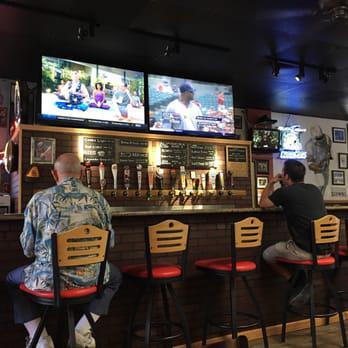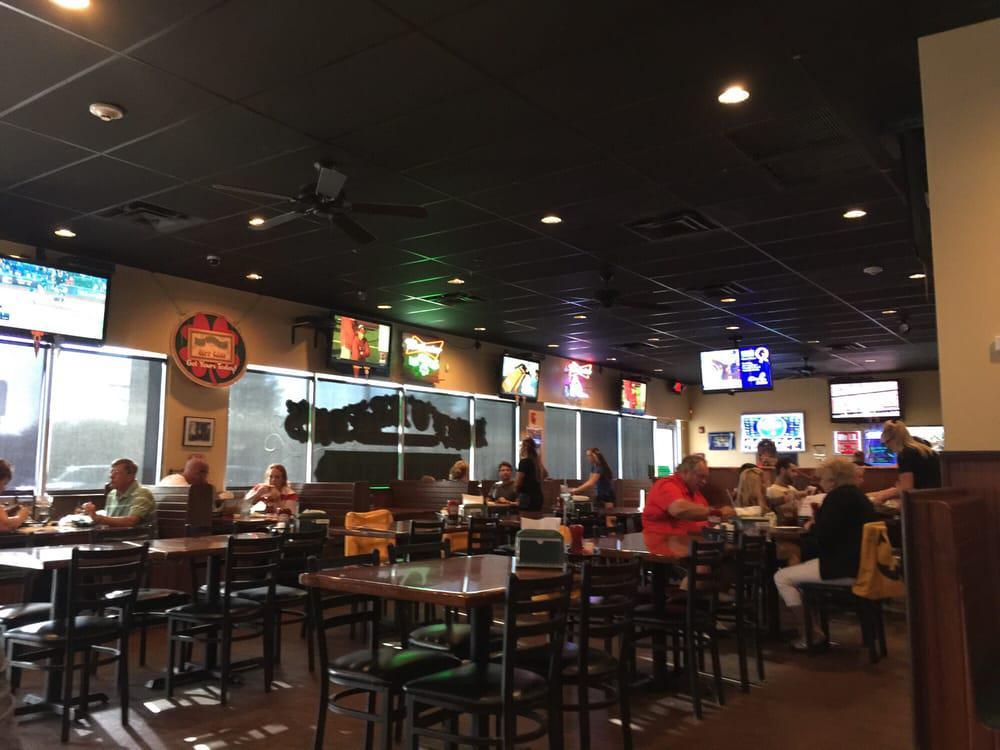The first image is the image on the left, the second image is the image on the right. Assess this claim about the two images: "A bar image includes no more than two customers in the foreground, sitting with back to the camera watching TV screens.". Correct or not? Answer yes or no. Yes. 